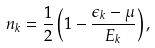<formula> <loc_0><loc_0><loc_500><loc_500>n _ { k } = \frac { 1 } { 2 } \left ( 1 - \frac { \epsilon _ { k } - \mu } { E _ { k } } \right ) ,</formula> 